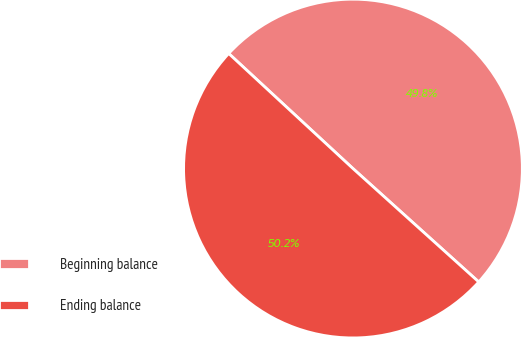<chart> <loc_0><loc_0><loc_500><loc_500><pie_chart><fcel>Beginning balance<fcel>Ending balance<nl><fcel>49.79%<fcel>50.21%<nl></chart> 